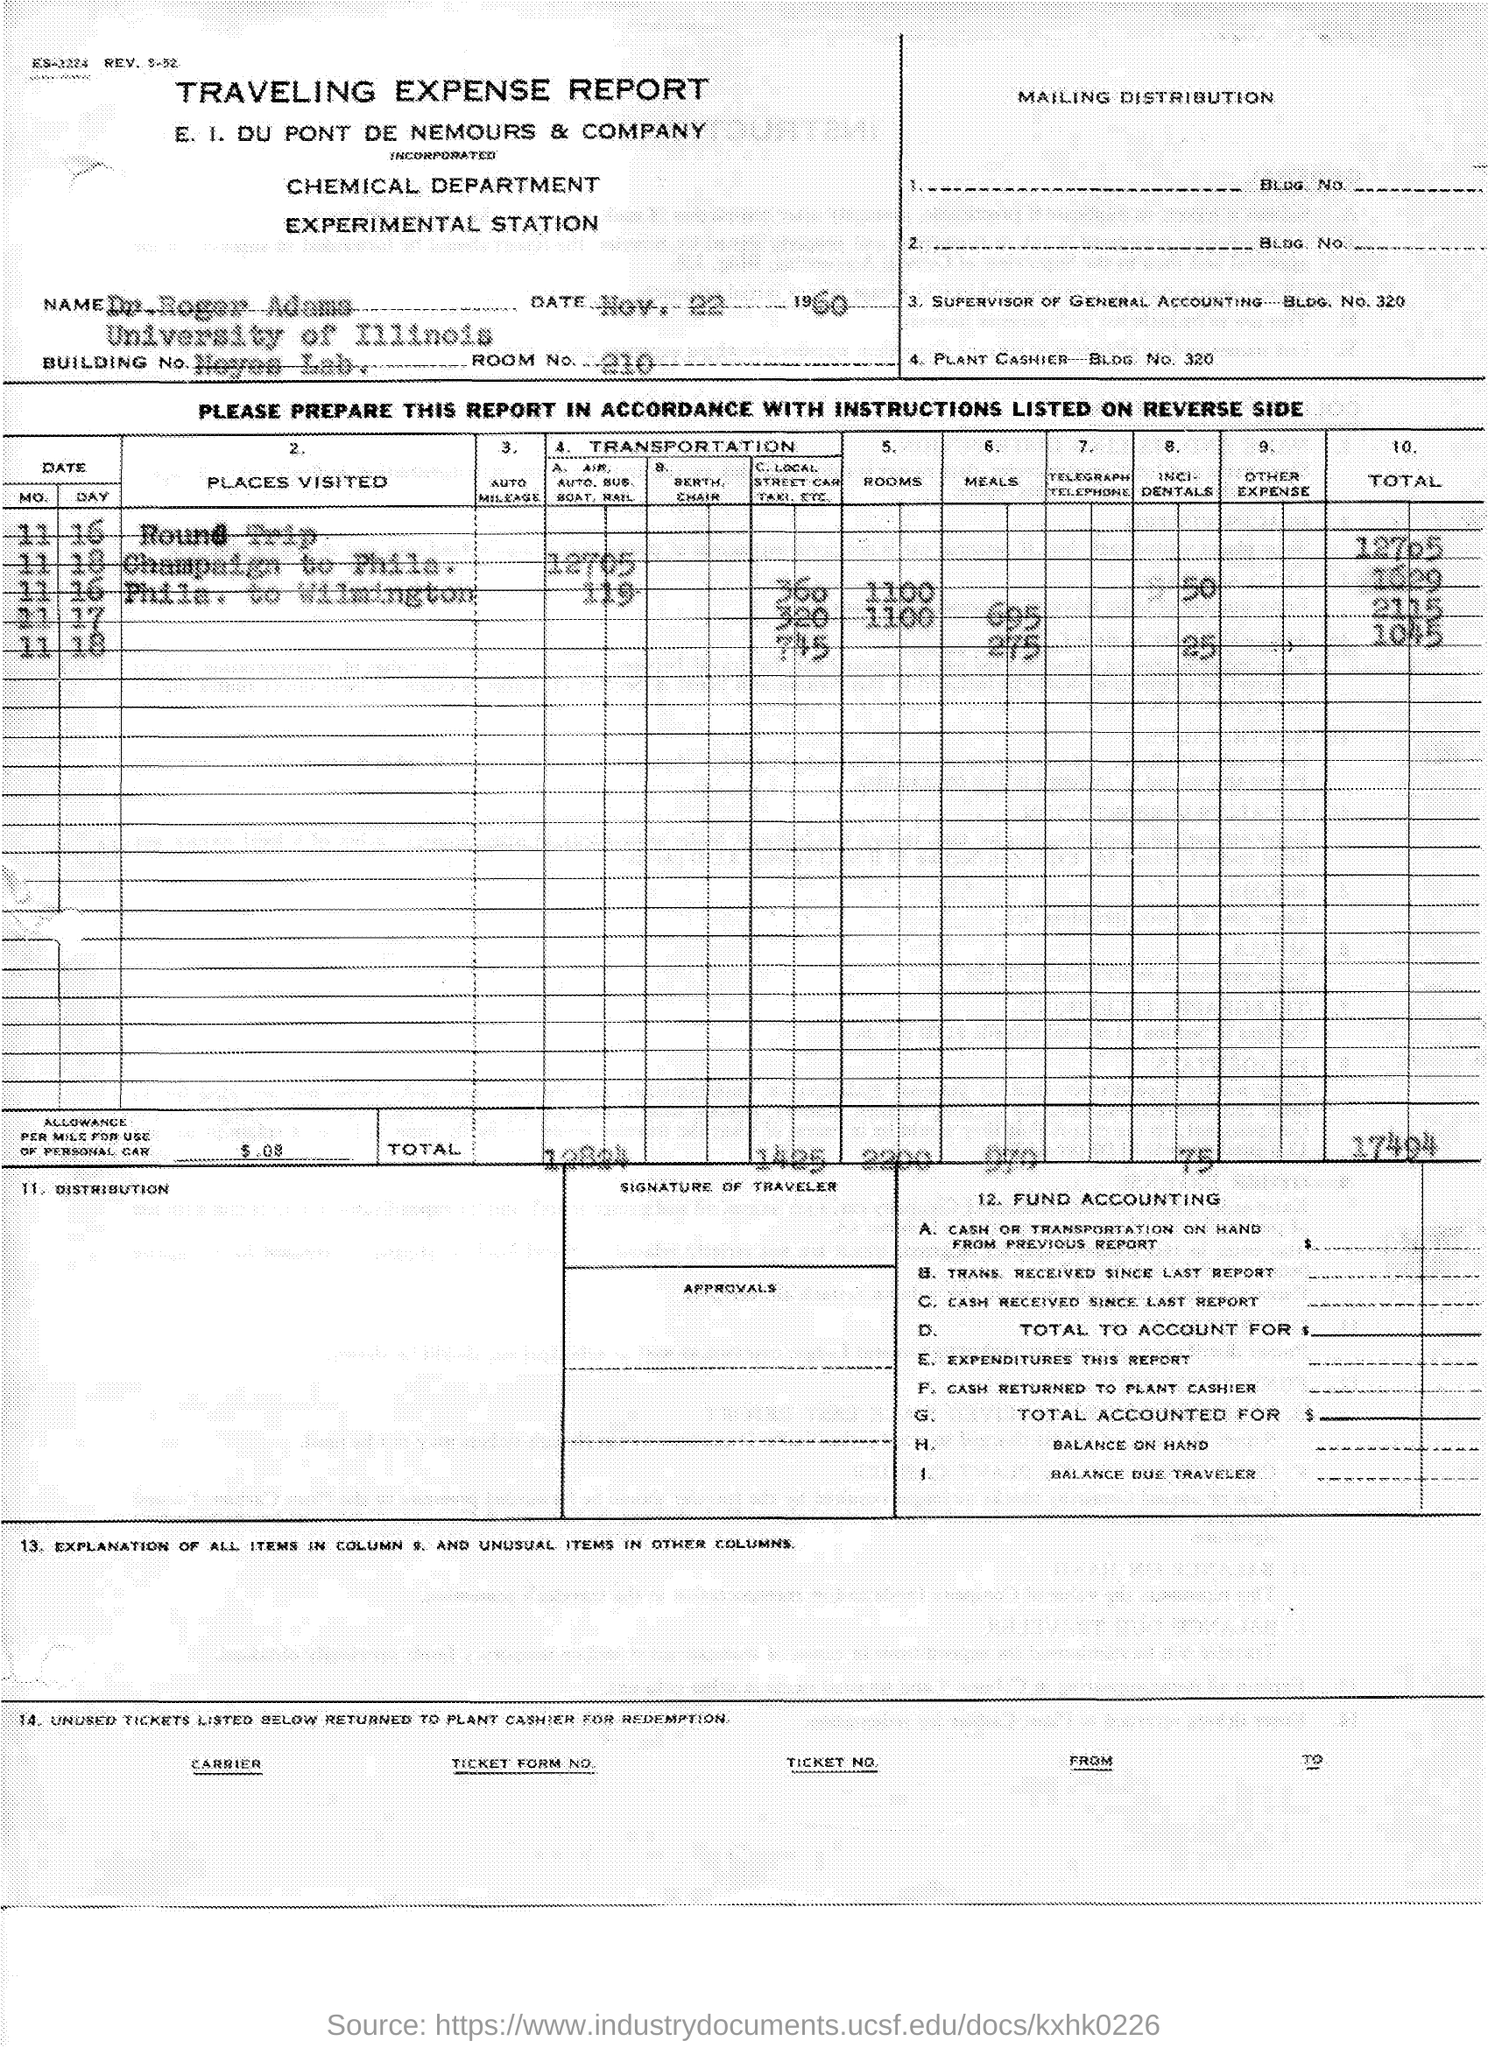Highlight a few significant elements in this photo. According to the given report, the allowance given per mile for the use of a personal car is 0.08. The date mentioned in the given report is November 22, 1960. The University of Illinois is the name of the university that is mentioned in the given report. The given report is titled "Traveling Expenses. The name mentioned in the given report is Dr. Roger Adams. 